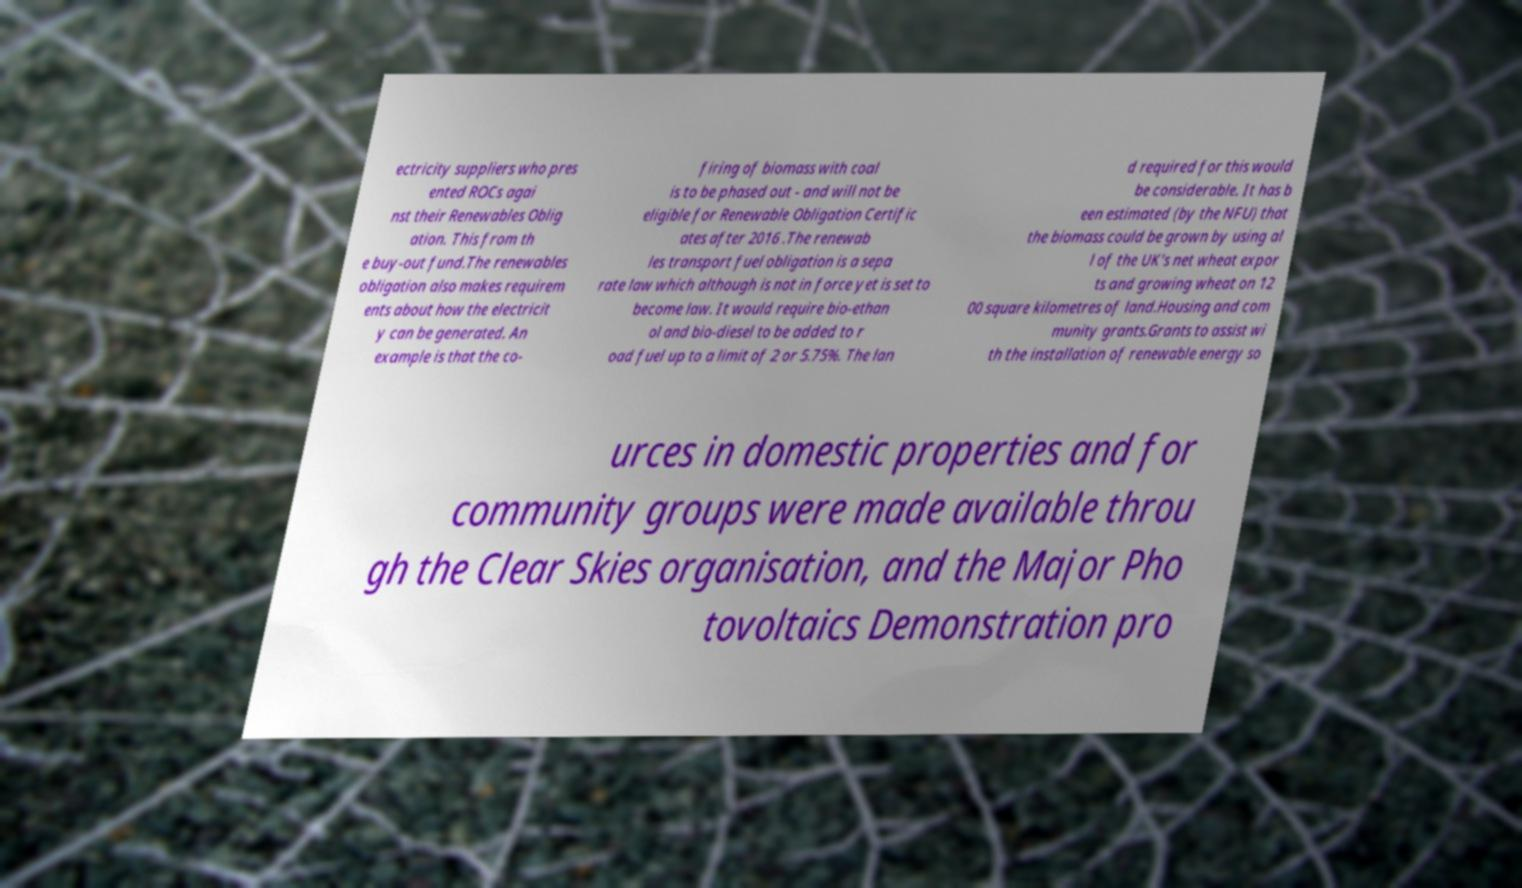For documentation purposes, I need the text within this image transcribed. Could you provide that? ectricity suppliers who pres ented ROCs agai nst their Renewables Oblig ation. This from th e buy-out fund.The renewables obligation also makes requirem ents about how the electricit y can be generated. An example is that the co- firing of biomass with coal is to be phased out - and will not be eligible for Renewable Obligation Certific ates after 2016 .The renewab les transport fuel obligation is a sepa rate law which although is not in force yet is set to become law. It would require bio-ethan ol and bio-diesel to be added to r oad fuel up to a limit of 2 or 5.75%. The lan d required for this would be considerable. It has b een estimated (by the NFU) that the biomass could be grown by using al l of the UK's net wheat expor ts and growing wheat on 12 00 square kilometres of land.Housing and com munity grants.Grants to assist wi th the installation of renewable energy so urces in domestic properties and for community groups were made available throu gh the Clear Skies organisation, and the Major Pho tovoltaics Demonstration pro 